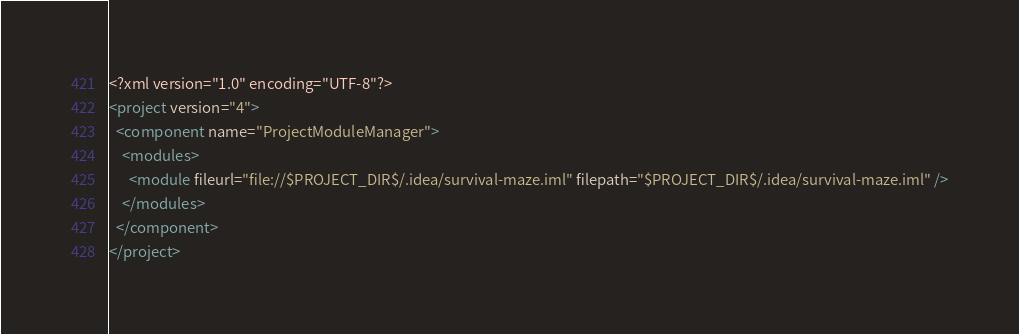Convert code to text. <code><loc_0><loc_0><loc_500><loc_500><_XML_><?xml version="1.0" encoding="UTF-8"?>
<project version="4">
  <component name="ProjectModuleManager">
    <modules>
      <module fileurl="file://$PROJECT_DIR$/.idea/survival-maze.iml" filepath="$PROJECT_DIR$/.idea/survival-maze.iml" />
    </modules>
  </component>
</project></code> 